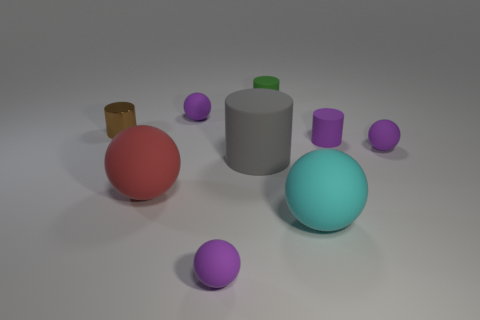Is the shape of the large thing that is to the left of the gray cylinder the same as the purple thing that is behind the brown cylinder?
Your answer should be very brief. Yes. The tiny rubber sphere in front of the big gray matte cylinder is what color?
Your response must be concise. Purple. Is the number of purple rubber things that are behind the small brown cylinder less than the number of cyan matte objects that are behind the large cyan rubber ball?
Ensure brevity in your answer.  No. How many other objects are there of the same material as the gray object?
Give a very brief answer. 7. Is the material of the green object the same as the small brown cylinder?
Provide a short and direct response. No. What number of other things are there of the same size as the brown cylinder?
Make the answer very short. 5. There is a purple ball to the right of the small matte ball that is in front of the gray object; how big is it?
Offer a very short reply. Small. What is the color of the big rubber ball on the left side of the small green matte thing behind the large matte sphere that is to the right of the big red ball?
Your answer should be compact. Red. There is a object that is both behind the small brown thing and in front of the small green matte cylinder; what size is it?
Keep it short and to the point. Small. What number of other things are the same shape as the big gray matte object?
Your answer should be very brief. 3. 